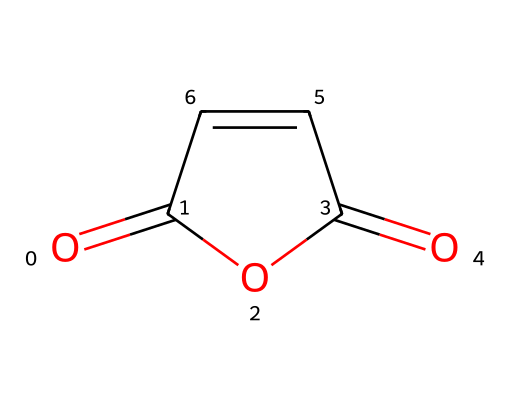What is the name of this chemical? The SMILES representation shows a compound with an anhydride functional group formed by the combination of two carboxylic acid segments. This specific arrangement corresponds to maleic anhydride, a well-known acid anhydride.
Answer: maleic anhydride How many carbon atoms are present in this molecule? By analyzing the SMILES notation, we can identify that there are four carbon atoms indicated by the structure C1, C, C, and another C within the cyclic arrangement.
Answer: 4 What type of functional groups does maleic anhydride contain? The molecule's structure shows the presence of an anhydride functional group (from the O=C and C(=O) connections) as well as a double bond (C=C) between two carbon atoms. This indicates that maleic anhydride contains both anhydride and alkene functional groups.
Answer: anhydride and alkene How many rings are present in the molecular structure? Inspecting the structure, we notice that there is a cyclic arrangement made with the carbon atoms (C1 and the closure back to C), confirming the presence of one ring in the compound.
Answer: 1 Which type of reaction can maleic anhydride undergo due to its structure? The presence of the anhydride and double bond makes this compound reactive, particularly in polymerization and condensation reactions, which are common with acid anhydrides as they can form ester linkages with alcohols or react with nucleophiles.
Answer: polymerization What is the hybridization of the carbon atoms involved in the double bond? The carbon atoms forming the double bond (C=C) are sp2 hybridized, which allows for one sigma bond and one pi bond between them, a characteristic of alkenes noted in the structure.
Answer: sp2 